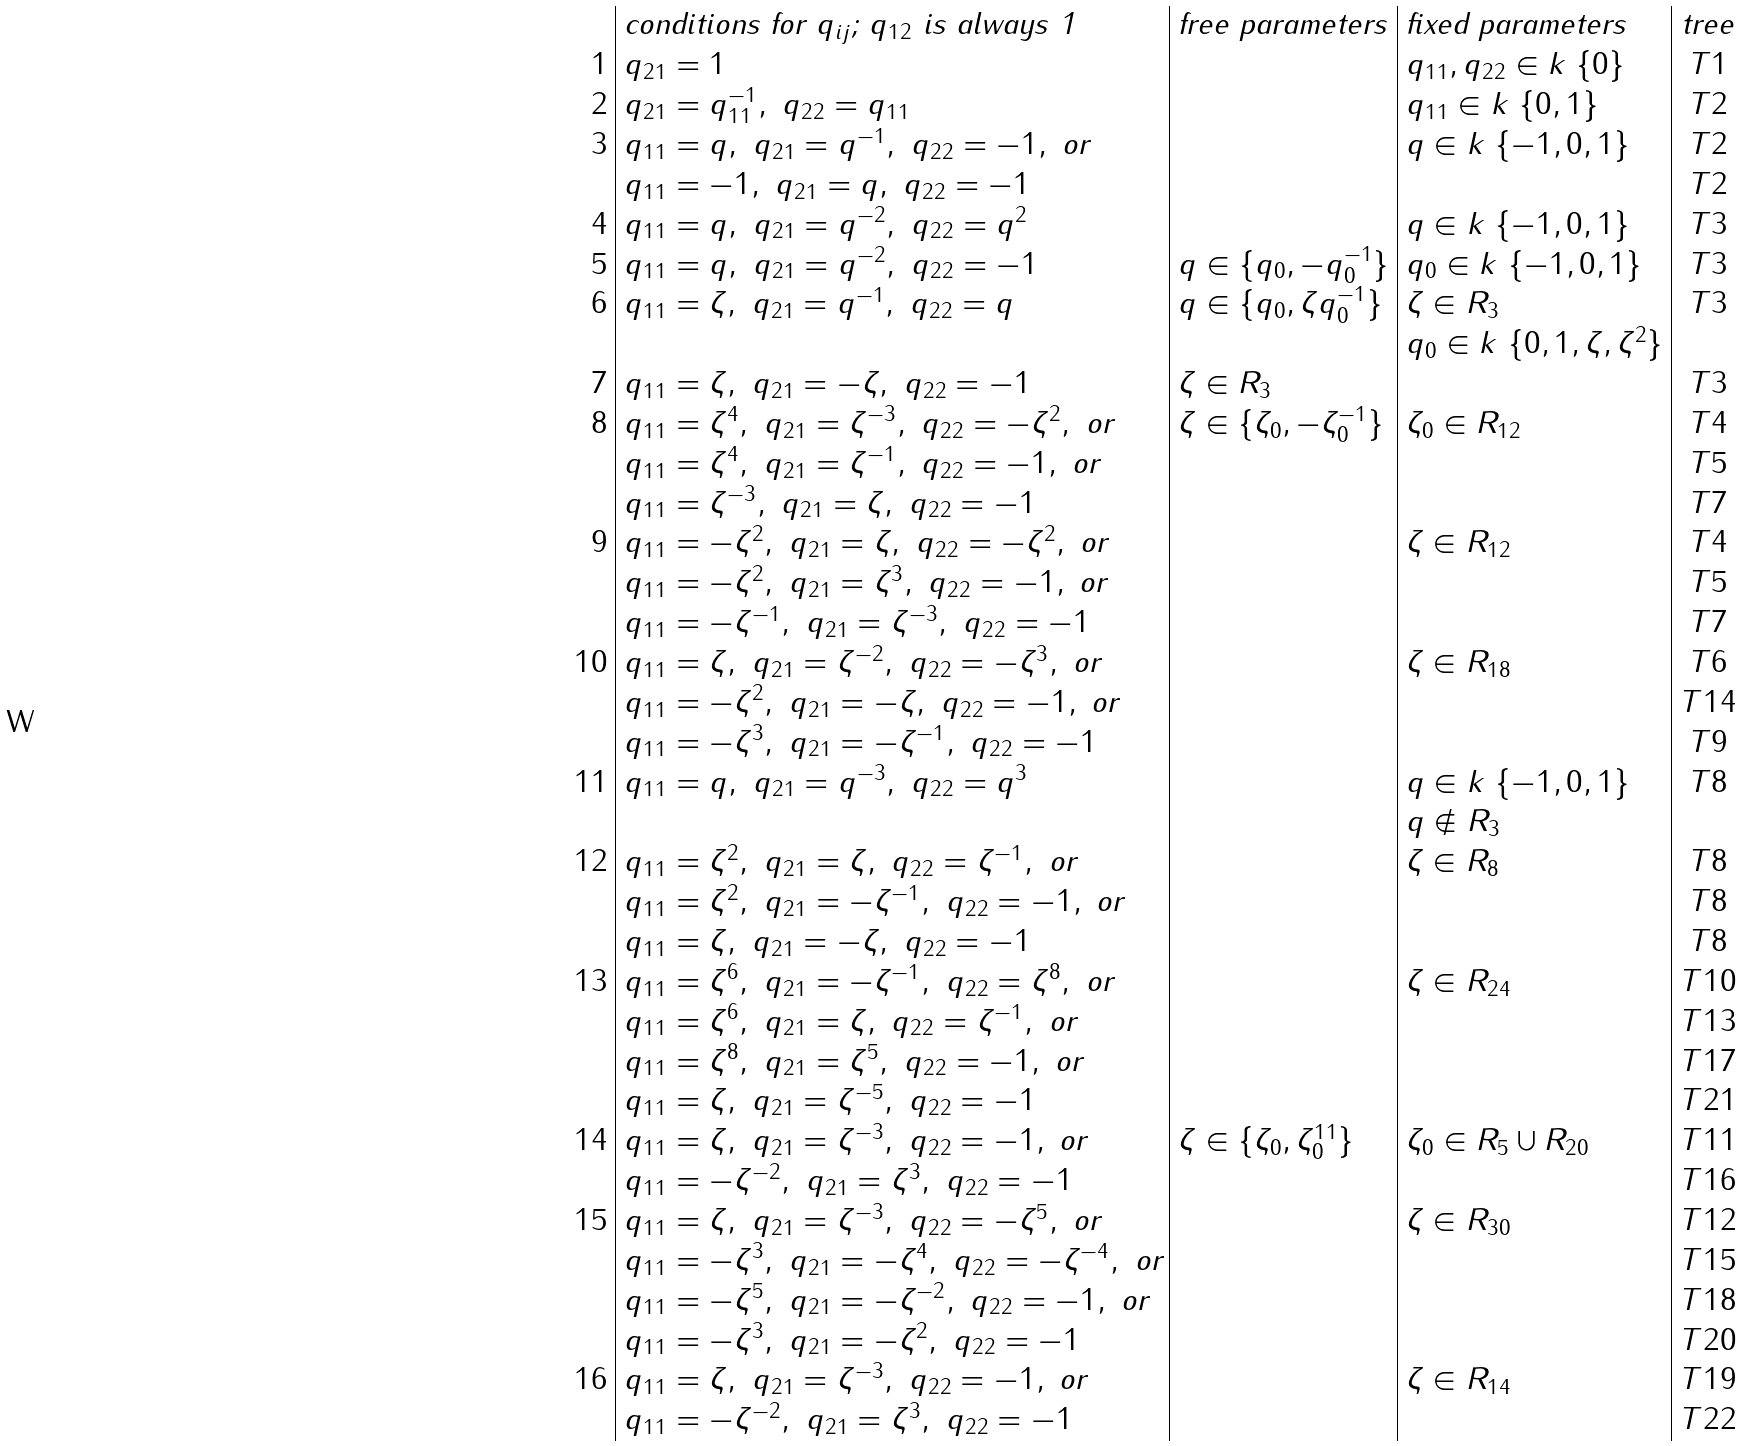<formula> <loc_0><loc_0><loc_500><loc_500>\begin{array} { r | l | l | l | c } & \text {conditions for $q_{ij}$; $q_{12}$ is always 1} & \text {free parameters} & \text {fixed parameters} & \text {tree} \\ 1 & q _ { 2 1 } = 1 & & q _ { 1 1 } , q _ { 2 2 } \in k \ \{ 0 \} & T 1 \\ 2 & q _ { 2 1 } = q _ { 1 1 } ^ { - 1 } , \ q _ { 2 2 } = q _ { 1 1 } & & q _ { 1 1 } \in k \ \{ 0 , 1 \} & T 2 \\ 3 & q _ { 1 1 } = q , \ q _ { 2 1 } = q ^ { - 1 } , \ q _ { 2 2 } = - 1 , \text { or} & & q \in k \ \{ - 1 , 0 , 1 \} & T 2 \\ & q _ { 1 1 } = - 1 , \ q _ { 2 1 } = q , \ q _ { 2 2 } = - 1 & & & T 2 \\ 4 & q _ { 1 1 } = q , \ q _ { 2 1 } = q ^ { - 2 } , \ q _ { 2 2 } = q ^ { 2 } & & q \in k \ \{ - 1 , 0 , 1 \} & T 3 \\ 5 & q _ { 1 1 } = q , \ q _ { 2 1 } = q ^ { - 2 } , \ q _ { 2 2 } = - 1 & q \in \{ q _ { 0 } , - q _ { 0 } ^ { - 1 } \} & q _ { 0 } \in k \ \{ - 1 , 0 , 1 \} & T 3 \\ 6 & q _ { 1 1 } = \zeta , \ q _ { 2 1 } = q ^ { - 1 } , \ q _ { 2 2 } = q & q \in \{ q _ { 0 } , \zeta q _ { 0 } ^ { - 1 } \} & \zeta \in R _ { 3 } & T 3 \\ & & & q _ { 0 } \in k \ \{ 0 , 1 , \zeta , \zeta ^ { 2 } \} & \\ 7 & q _ { 1 1 } = \zeta , \ q _ { 2 1 } = - \zeta , \ q _ { 2 2 } = - 1 & \zeta \in R _ { 3 } & & T 3 \\ 8 & q _ { 1 1 } = \zeta ^ { 4 } , \ q _ { 2 1 } = \zeta ^ { - 3 } , \ q _ { 2 2 } = - \zeta ^ { 2 } , \text { or} & \zeta \in \{ \zeta _ { 0 } , - \zeta _ { 0 } ^ { - 1 } \} & \zeta _ { 0 } \in R _ { 1 2 } & T 4 \\ & q _ { 1 1 } = \zeta ^ { 4 } , \ q _ { 2 1 } = \zeta ^ { - 1 } , \ q _ { 2 2 } = - 1 , \text { or} & & & T 5 \\ & q _ { 1 1 } = \zeta ^ { - 3 } , \ q _ { 2 1 } = \zeta , \ q _ { 2 2 } = - 1 & & & T 7 \\ 9 & q _ { 1 1 } = - \zeta ^ { 2 } , \ q _ { 2 1 } = \zeta , \ q _ { 2 2 } = - \zeta ^ { 2 } , \text { or} & & \zeta \in R _ { 1 2 } & T 4 \\ & q _ { 1 1 } = - \zeta ^ { 2 } , \ q _ { 2 1 } = \zeta ^ { 3 } , \ q _ { 2 2 } = - 1 , \text { or} & & & T 5 \\ & q _ { 1 1 } = - \zeta ^ { - 1 } , \ q _ { 2 1 } = \zeta ^ { - 3 } , \ q _ { 2 2 } = - 1 & & & T 7 \\ 1 0 & q _ { 1 1 } = \zeta , \ q _ { 2 1 } = \zeta ^ { - 2 } , \ q _ { 2 2 } = - \zeta ^ { 3 } , \text { or} & & \zeta \in R _ { 1 8 } & T 6 \\ & q _ { 1 1 } = - \zeta ^ { 2 } , \ q _ { 2 1 } = - \zeta , \ q _ { 2 2 } = - 1 , \text { or} & & & T 1 4 \\ & q _ { 1 1 } = - \zeta ^ { 3 } , \ q _ { 2 1 } = - \zeta ^ { - 1 } , \ q _ { 2 2 } = - 1 & & & T 9 \\ 1 1 & q _ { 1 1 } = q , \ q _ { 2 1 } = q ^ { - 3 } , \ q _ { 2 2 } = q ^ { 3 } & & q \in k \ \{ - 1 , 0 , 1 \} & T 8 \\ & & & q \notin R _ { 3 } & \\ 1 2 & q _ { 1 1 } = \zeta ^ { 2 } , \ q _ { 2 1 } = \zeta , \ q _ { 2 2 } = \zeta ^ { - 1 } , \text { or} & & \zeta \in R _ { 8 } & T 8 \\ & q _ { 1 1 } = \zeta ^ { 2 } , \ q _ { 2 1 } = - \zeta ^ { - 1 } , \ q _ { 2 2 } = - 1 , \text { or} & & & T 8 \\ & q _ { 1 1 } = \zeta , \ q _ { 2 1 } = - \zeta , \ q _ { 2 2 } = - 1 & & & T 8 \\ 1 3 & q _ { 1 1 } = \zeta ^ { 6 } , \ q _ { 2 1 } = - \zeta ^ { - 1 } , \ q _ { 2 2 } = \zeta ^ { 8 } , \text { or} & & \zeta \in R _ { 2 4 } & T 1 0 \\ & q _ { 1 1 } = \zeta ^ { 6 } , \ q _ { 2 1 } = \zeta , \ q _ { 2 2 } = \zeta ^ { - 1 } , \text { or} & & & T 1 3 \\ & q _ { 1 1 } = \zeta ^ { 8 } , \ q _ { 2 1 } = \zeta ^ { 5 } , \ q _ { 2 2 } = - 1 , \text { or} & & & T 1 7 \\ & q _ { 1 1 } = \zeta , \ q _ { 2 1 } = \zeta ^ { - 5 } , \ q _ { 2 2 } = - 1 & & & T 2 1 \\ 1 4 & q _ { 1 1 } = \zeta , \ q _ { 2 1 } = \zeta ^ { - 3 } , \ q _ { 2 2 } = - 1 , \text { or} & \zeta \in \{ \zeta _ { 0 } , \zeta _ { 0 } ^ { 1 1 } \} & \zeta _ { 0 } \in R _ { 5 } \cup R _ { 2 0 } & T 1 1 \\ & q _ { 1 1 } = - \zeta ^ { - 2 } , \ q _ { 2 1 } = \zeta ^ { 3 } , \ q _ { 2 2 } = - 1 & & & T 1 6 \\ 1 5 & q _ { 1 1 } = \zeta , \ q _ { 2 1 } = \zeta ^ { - 3 } , \ q _ { 2 2 } = - \zeta ^ { 5 } , \text { or} & & \zeta \in R _ { 3 0 } & T 1 2 \\ & q _ { 1 1 } = - \zeta ^ { 3 } , \ q _ { 2 1 } = - \zeta ^ { 4 } , \ q _ { 2 2 } = - \zeta ^ { - 4 } , \text { or} & & & T 1 5 \\ & q _ { 1 1 } = - \zeta ^ { 5 } , \ q _ { 2 1 } = - \zeta ^ { - 2 } , \ q _ { 2 2 } = - 1 , \text { or} & & & T 1 8 \\ & q _ { 1 1 } = - \zeta ^ { 3 } , \ q _ { 2 1 } = - \zeta ^ { 2 } , \ q _ { 2 2 } = - 1 & & & T 2 0 \\ 1 6 & q _ { 1 1 } = \zeta , \ q _ { 2 1 } = \zeta ^ { - 3 } , \ q _ { 2 2 } = - 1 , \text { or} & & \zeta \in R _ { 1 4 } & T 1 9 \\ & q _ { 1 1 } = - \zeta ^ { - 2 } , \ q _ { 2 1 } = \zeta ^ { 3 } , \ q _ { 2 2 } = - 1 & & & T 2 2 \\ \end{array}</formula> 